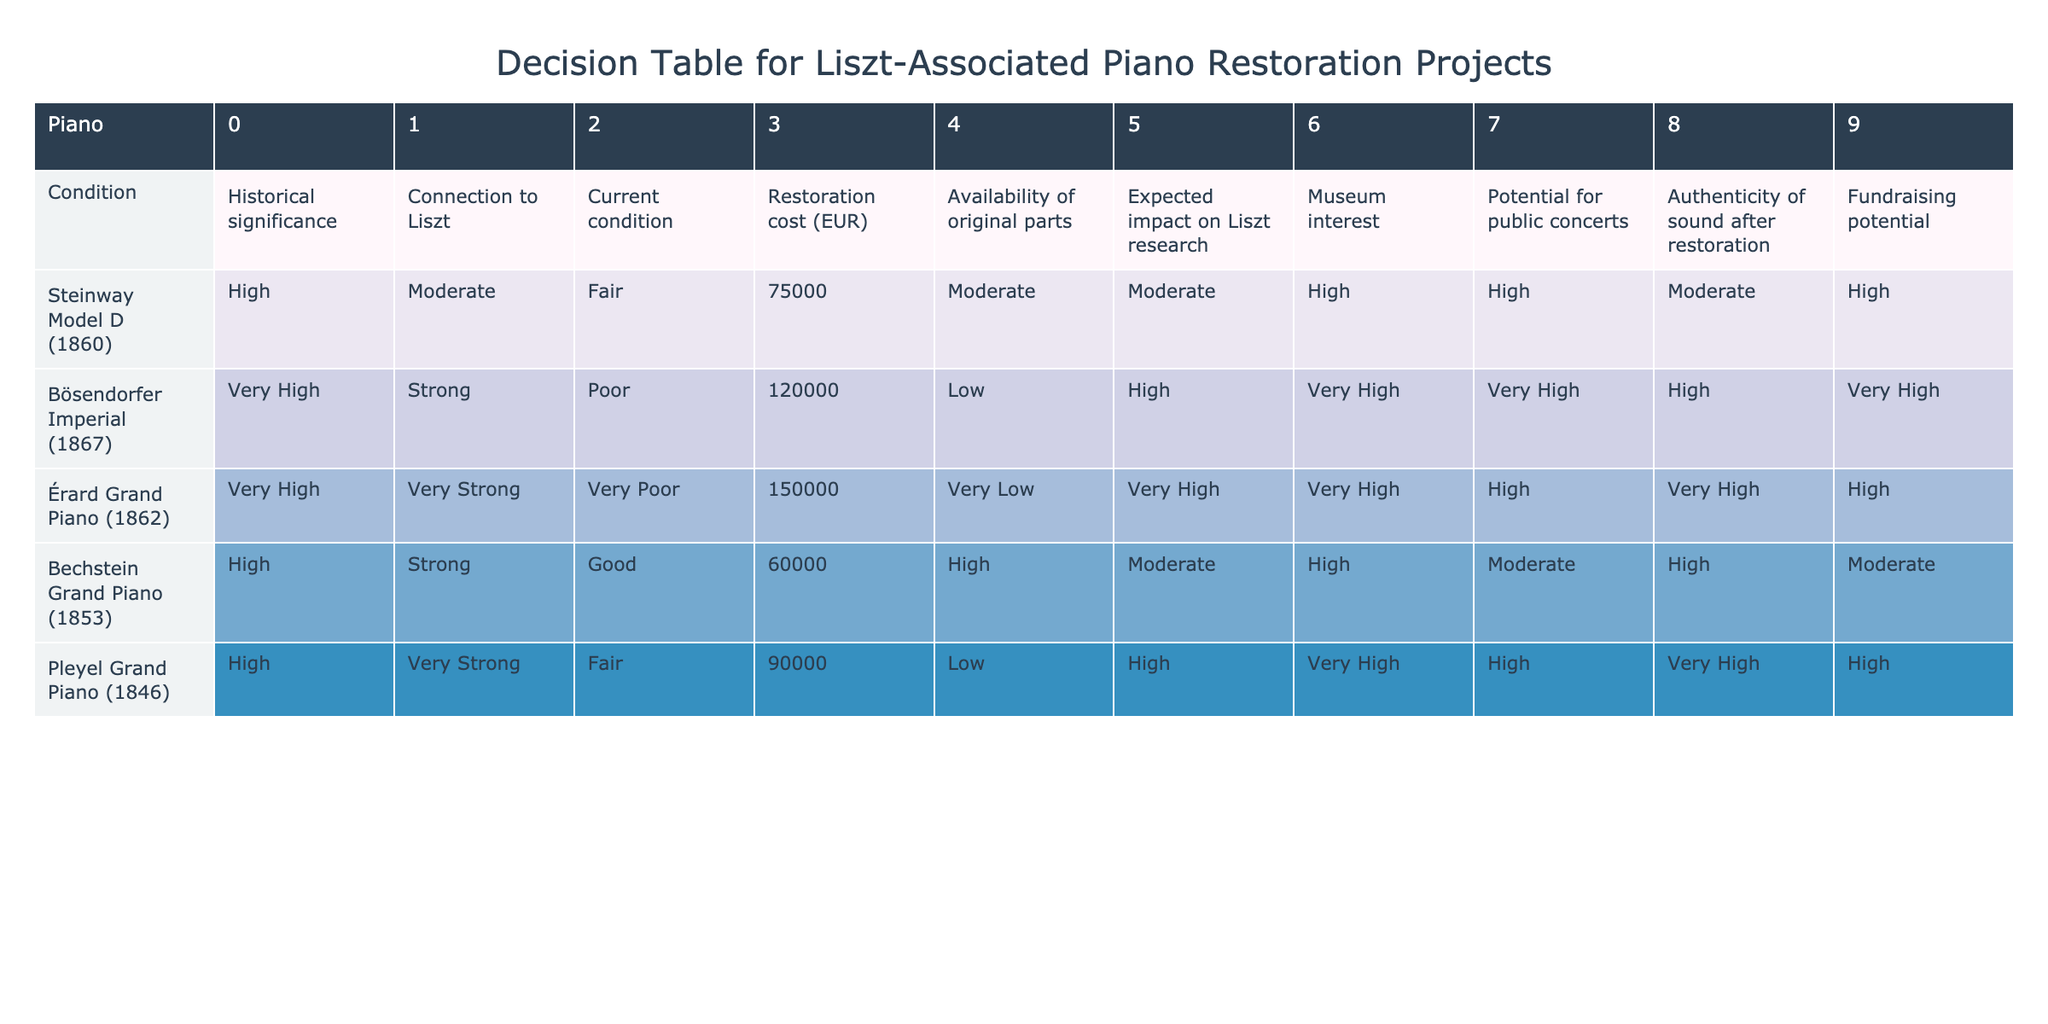What is the restoration cost of the Bösendorfer Imperial? The table shows the restoration cost of the Bösendorfer Imperial as 120000 EUR.
Answer: 120000 EUR Which piano has the highest historical significance rating? The Bösendorfer Imperial and Érard Grand Piano both have a "Very High" historical significance rating, which is the highest category.
Answer: Bösendorfer Imperial and Érard Grand Piano How many pianos have a 'High' potential for public concerts? The Steinway Model D, Bösendorfer Imperial, and Pleyel Grand Piano each have a 'High' potential for public concerts. Therefore, there are three pianos in this category.
Answer: 3 Is the expected impact on Liszt research for the Érard Grand Piano classified as "Very High"? Yes, the expected impact on Liszt research for the Érard Grand Piano is indeed classified as "Very High" according to the table.
Answer: Yes What is the average restoration cost of pianos with a 'Very Strong' connection to Liszt? The pianos with a 'Very Strong' connection to Liszt are the Érard Grand Piano and Pleyel Grand Piano, with restoration costs of 150000 EUR and 90000 EUR respectively. The sum is 240000 EUR, and there are 2 pianos, so the average cost is 240000 EUR / 2 = 120000 EUR.
Answer: 120000 EUR Which piano has the lowest availability of original parts, and what is its rating? The Érard Grand Piano has the lowest availability of original parts, rated as 'Very Low'.
Answer: Érard Grand Piano, Very Low Does the Bechstein Grand Piano have a 'Very High' rating in any category? No, the Bechstein Grand Piano does not have a 'Very High' rating in any category; it has 'High' ratings in all categories except for 'Connection to Liszt' which is 'Strong'.
Answer: No How does the current condition of the Steinway Model D compare to the Pleyel Grand Piano? The Steinway Model D is rated as 'Fair' while the Pleyel Grand Piano is rated as 'Fair' as well, indicating they have the same current condition.
Answer: They are the same: Fair 